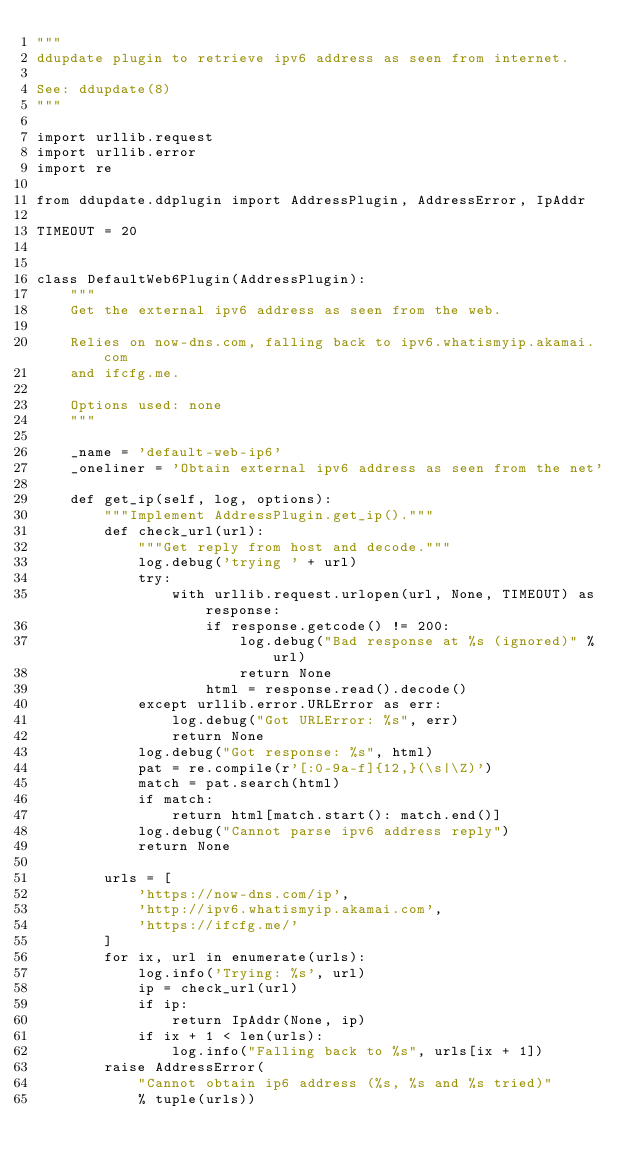<code> <loc_0><loc_0><loc_500><loc_500><_Python_>"""
ddupdate plugin to retrieve ipv6 address as seen from internet.

See: ddupdate(8)
"""

import urllib.request
import urllib.error
import re

from ddupdate.ddplugin import AddressPlugin, AddressError, IpAddr

TIMEOUT = 20


class DefaultWeb6Plugin(AddressPlugin):
    """
    Get the external ipv6 address as seen from the web.

    Relies on now-dns.com, falling back to ipv6.whatismyip.akamai.com
    and ifcfg.me.

    Options used: none
    """

    _name = 'default-web-ip6'
    _oneliner = 'Obtain external ipv6 address as seen from the net'

    def get_ip(self, log, options):
        """Implement AddressPlugin.get_ip()."""
        def check_url(url):
            """Get reply from host and decode."""
            log.debug('trying ' + url)
            try:
                with urllib.request.urlopen(url, None, TIMEOUT) as response:
                    if response.getcode() != 200:
                        log.debug("Bad response at %s (ignored)" % url)
                        return None
                    html = response.read().decode()
            except urllib.error.URLError as err:
                log.debug("Got URLError: %s", err)
                return None
            log.debug("Got response: %s", html)
            pat = re.compile(r'[:0-9a-f]{12,}(\s|\Z)')
            match = pat.search(html)
            if match:
                return html[match.start(): match.end()]
            log.debug("Cannot parse ipv6 address reply")
            return None

        urls = [
            'https://now-dns.com/ip',
            'http://ipv6.whatismyip.akamai.com',
            'https://ifcfg.me/'
        ]
        for ix, url in enumerate(urls):
            log.info('Trying: %s', url)
            ip = check_url(url)
            if ip:
                return IpAddr(None, ip)
            if ix + 1 < len(urls):
                log.info("Falling back to %s", urls[ix + 1])
        raise AddressError(
            "Cannot obtain ip6 address (%s, %s and %s tried)"
            % tuple(urls))
</code> 